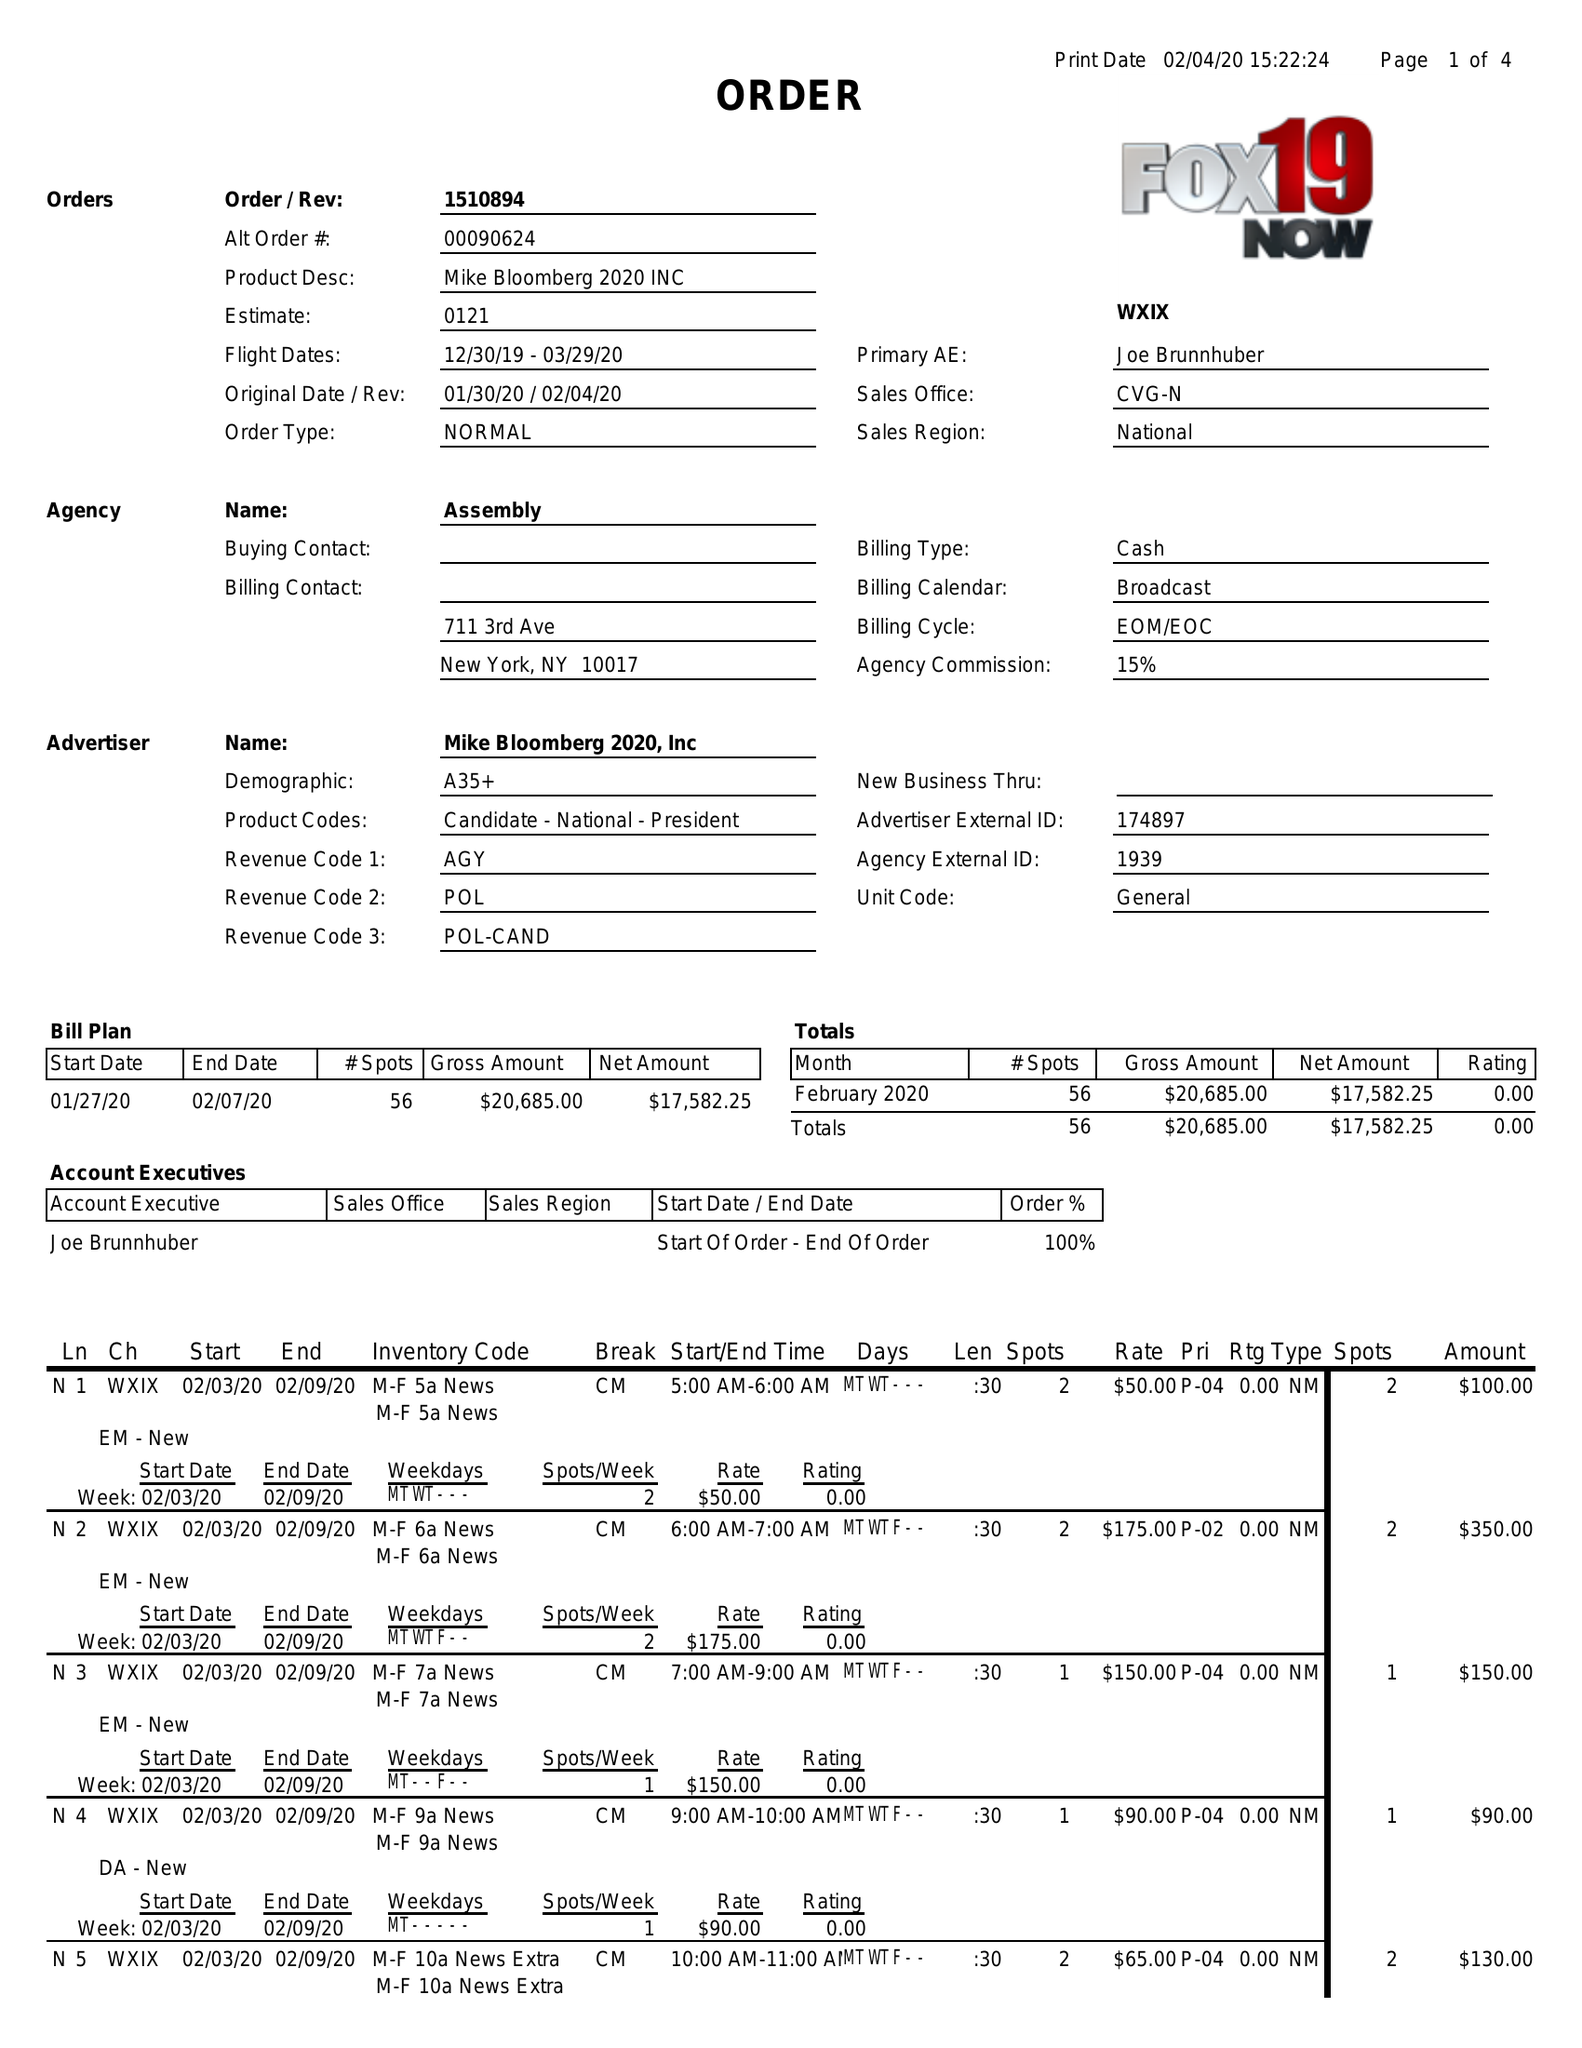What is the value for the flight_from?
Answer the question using a single word or phrase. 12/30/19 